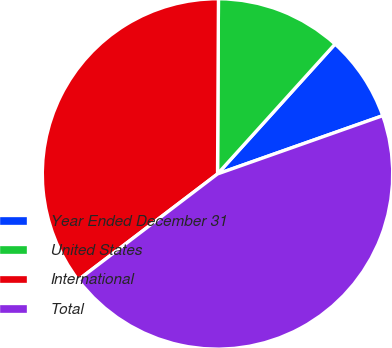<chart> <loc_0><loc_0><loc_500><loc_500><pie_chart><fcel>Year Ended December 31<fcel>United States<fcel>International<fcel>Total<nl><fcel>7.9%<fcel>11.62%<fcel>35.43%<fcel>45.05%<nl></chart> 